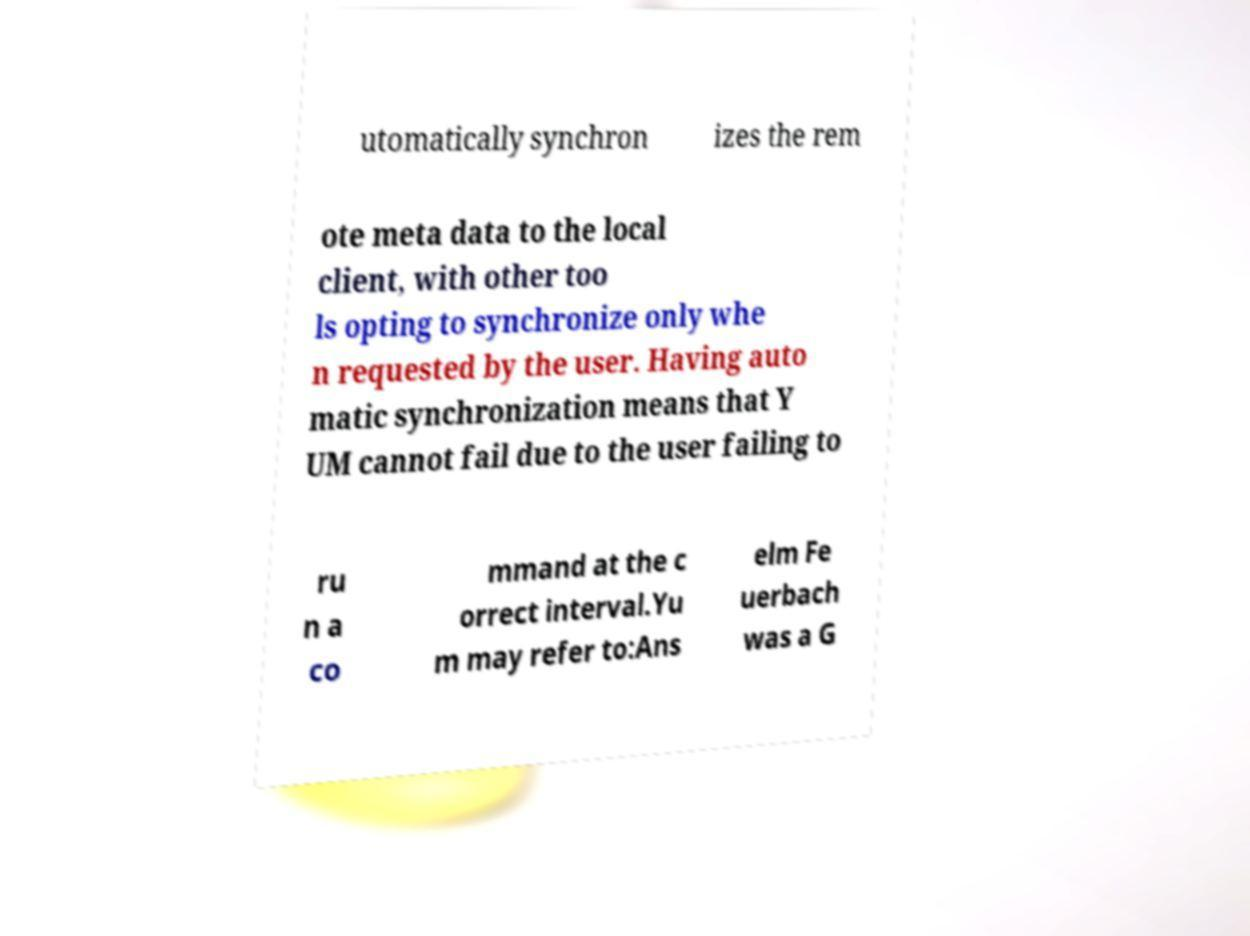I need the written content from this picture converted into text. Can you do that? utomatically synchron izes the rem ote meta data to the local client, with other too ls opting to synchronize only whe n requested by the user. Having auto matic synchronization means that Y UM cannot fail due to the user failing to ru n a co mmand at the c orrect interval.Yu m may refer to:Ans elm Fe uerbach was a G 